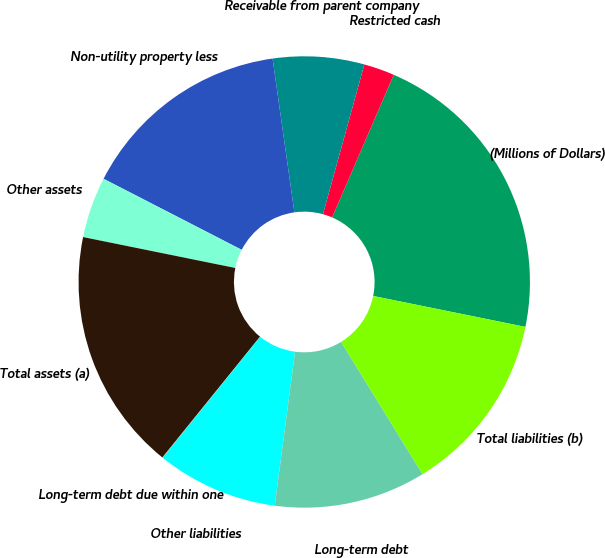Convert chart. <chart><loc_0><loc_0><loc_500><loc_500><pie_chart><fcel>(Millions of Dollars)<fcel>Restricted cash<fcel>Receivable from parent company<fcel>Non-utility property less<fcel>Other assets<fcel>Total assets (a)<fcel>Long-term debt due within one<fcel>Other liabilities<fcel>Long-term debt<fcel>Total liabilities (b)<nl><fcel>21.7%<fcel>2.2%<fcel>6.53%<fcel>15.2%<fcel>4.37%<fcel>17.37%<fcel>0.03%<fcel>8.7%<fcel>10.87%<fcel>13.03%<nl></chart> 